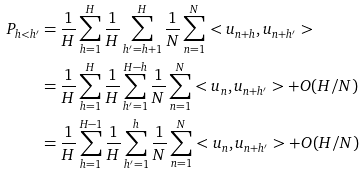Convert formula to latex. <formula><loc_0><loc_0><loc_500><loc_500>P _ { h < h ^ { \prime } } & = \frac { 1 } { H } \sum _ { h = 1 } ^ { H } \frac { 1 } { H } \sum _ { h ^ { \prime } = h + 1 } ^ { H } \frac { 1 } { N } \sum _ { n = 1 } ^ { N } < u _ { n + h } , u _ { n + h ^ { \prime } } > \\ & = \frac { 1 } { H } \sum _ { h = 1 } ^ { H } \frac { 1 } { H } \sum _ { h ^ { \prime } = 1 } ^ { H - h } \frac { 1 } { N } \sum _ { n = 1 } ^ { N } < u _ { n } , u _ { n + h ^ { \prime } } > + O ( H / N ) \\ & = \frac { 1 } { H } \sum _ { h = 1 } ^ { H - 1 } \frac { 1 } { H } \sum _ { h ^ { \prime } = 1 } ^ { h } \frac { 1 } { N } \sum _ { n = 1 } ^ { N } < u _ { n } , u _ { n + h ^ { \prime } } > + O ( H / N ) \\</formula> 